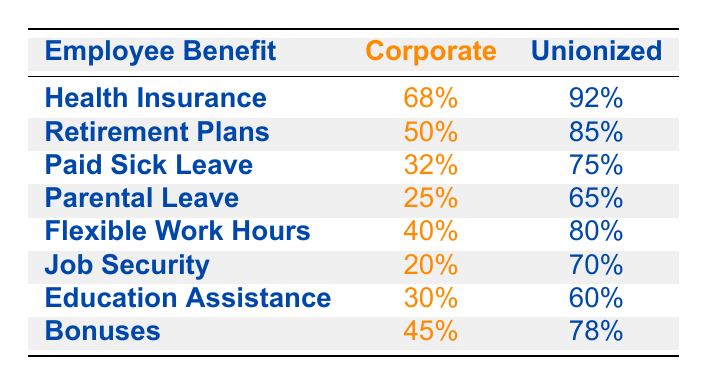What percentage of unionized workers receive health insurance? According to the table, 92% of unionized workers receive health insurance.
Answer: 92% What percentage of corporate employees have access to paid sick leave? The table states that 32% of corporate employees have access to paid sick leave.
Answer: 32% How many employee benefits are offered more often to unionized workers than to corporate employees? By comparing each benefit, we find that all employee benefits have a higher percentage for unionized workers than for corporate employees, making a total of 8 benefits.
Answer: 8 What is the difference in the percentage of employees receiving retirement plans between corporate and unionized workers? The percentage for corporate workers is 50%, while for unionized workers, it is 85%. The difference is calculated as 85% - 50%, resulting in a 35% difference.
Answer: 35% Do more corporate employees or unionized workers have access to education assistance? The table shows that 30% of corporate employees have access to education assistance, while 60% of unionized workers do, indicating that more unionized workers have access.
Answer: Yes Which employee benefit has the largest gap between corporate and unionized workers? By reviewing the table, the benefit "Retirement Plans" shows the largest gap: 85% for unionized versus 50% for corporate, resulting in a 35% difference.
Answer: Retirement Plans What is the average percentage of health insurance and job security for corporate employees? The percentages for health insurance and job security for corporate employees are 68% and 20%, respectively. The sum is 68% + 20% = 88%. To find the average, we divide by 2 (88% / 2) = 44%.
Answer: 44% How many benefits do unionized workers receive at a percentage of 75% or higher? By examining the table, the benefits that unionized workers receive at or above 75% are: Health Insurance (92%), Retirement Plans (85%), Paid Sick Leave (75%), Parental Leave (65%), Flexible Work Hours (80%), Job Security (70%), and Bonuses (78%). Only 5 benefits meet this criterion.
Answer: 5 